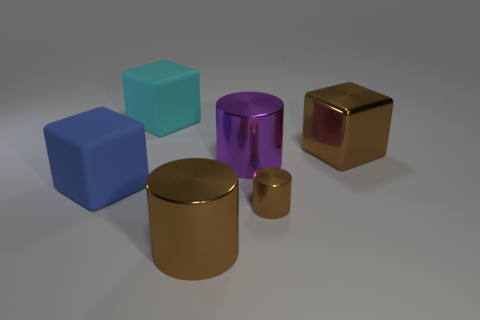Add 4 big purple metallic cylinders. How many objects exist? 10 Subtract 0 green cubes. How many objects are left? 6 Subtract all large metallic spheres. Subtract all blue rubber things. How many objects are left? 5 Add 3 brown cylinders. How many brown cylinders are left? 5 Add 6 shiny objects. How many shiny objects exist? 10 